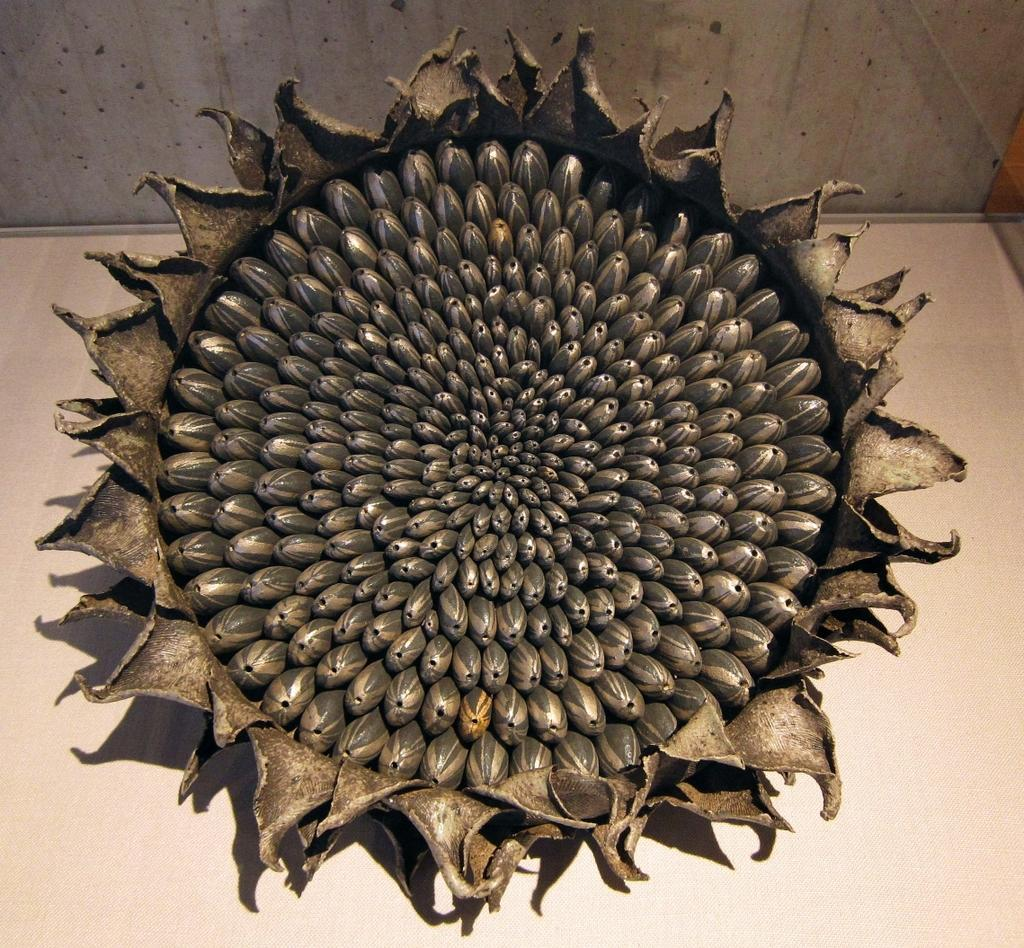What type of plant is in the image? There is a dry sunflower in the image. Where is the sunflower located? The sunflower is placed on a surface. What can be seen in the background of the image? There is a wall in the background of the image. What type of pie is being served on the grass in the image? There is no pie or grass present in the image; it features a dry sunflower placed on a surface with a wall in the background. 